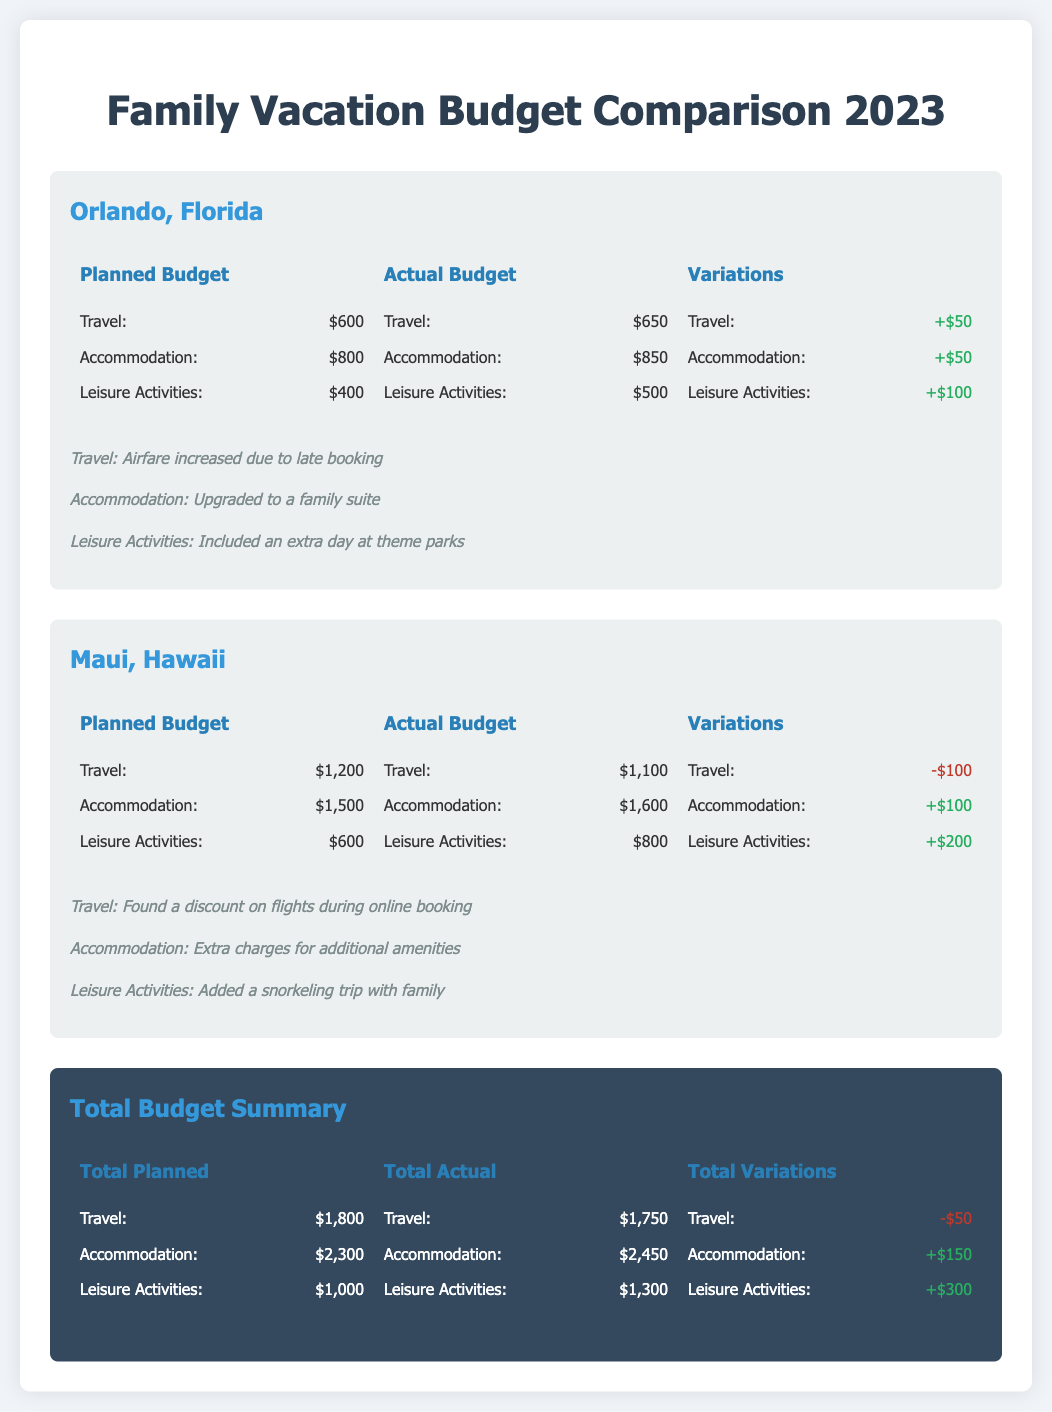What was the planned budget for travel to Orlando? The planned budget is listed as $600 in the document for travel to Orlando.
Answer: $600 What was the actual budget for accommodation in Maui? The actual budget for accommodation in Maui is shown as $1,600.
Answer: $1,600 How much was spent on leisure activities in Orlando compared to the planned budget? The budget document states there was an increase of $100 in leisure activities compared to the planned budget of $400.
Answer: $100 What is the total planned budget for leisure activities across both vacations? The planned budgets for leisure activities are $400 for Orlando and $600 for Maui, totaling $1,000.
Answer: $1,000 What was the variation in travel costs for Orlando? The variation in travel costs for Orlando is a positive $50, as indicated in the comparison section.
Answer: +$50 What is the total actual budget for travel across both vacations? The actual budgets for travel are $650 for Orlando and $1,100 for Maui, totaling $1,750.
Answer: $1,750 How much more was spent on accommodation in Maui compared to the planned budget? The accommodation in Maui had a positive variation of $100 compared to the planned budget.
Answer: +$100 Which vacation had the higher actual expenditure on leisure activities? The document indicates that leisure activities cost $800 in Maui, which is higher than the Orlando expenditure of $500.
Answer: Maui What is the total variation in accommodation costs across both vacations? The total variations in accommodation are $50 for Orlando and $100 for Maui, totaling $150.
Answer: +$150 